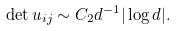<formula> <loc_0><loc_0><loc_500><loc_500>\det u _ { i j } \sim C _ { 2 } d ^ { - 1 } | \log d | .</formula> 